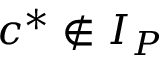Convert formula to latex. <formula><loc_0><loc_0><loc_500><loc_500>c ^ { * } \notin I _ { P }</formula> 